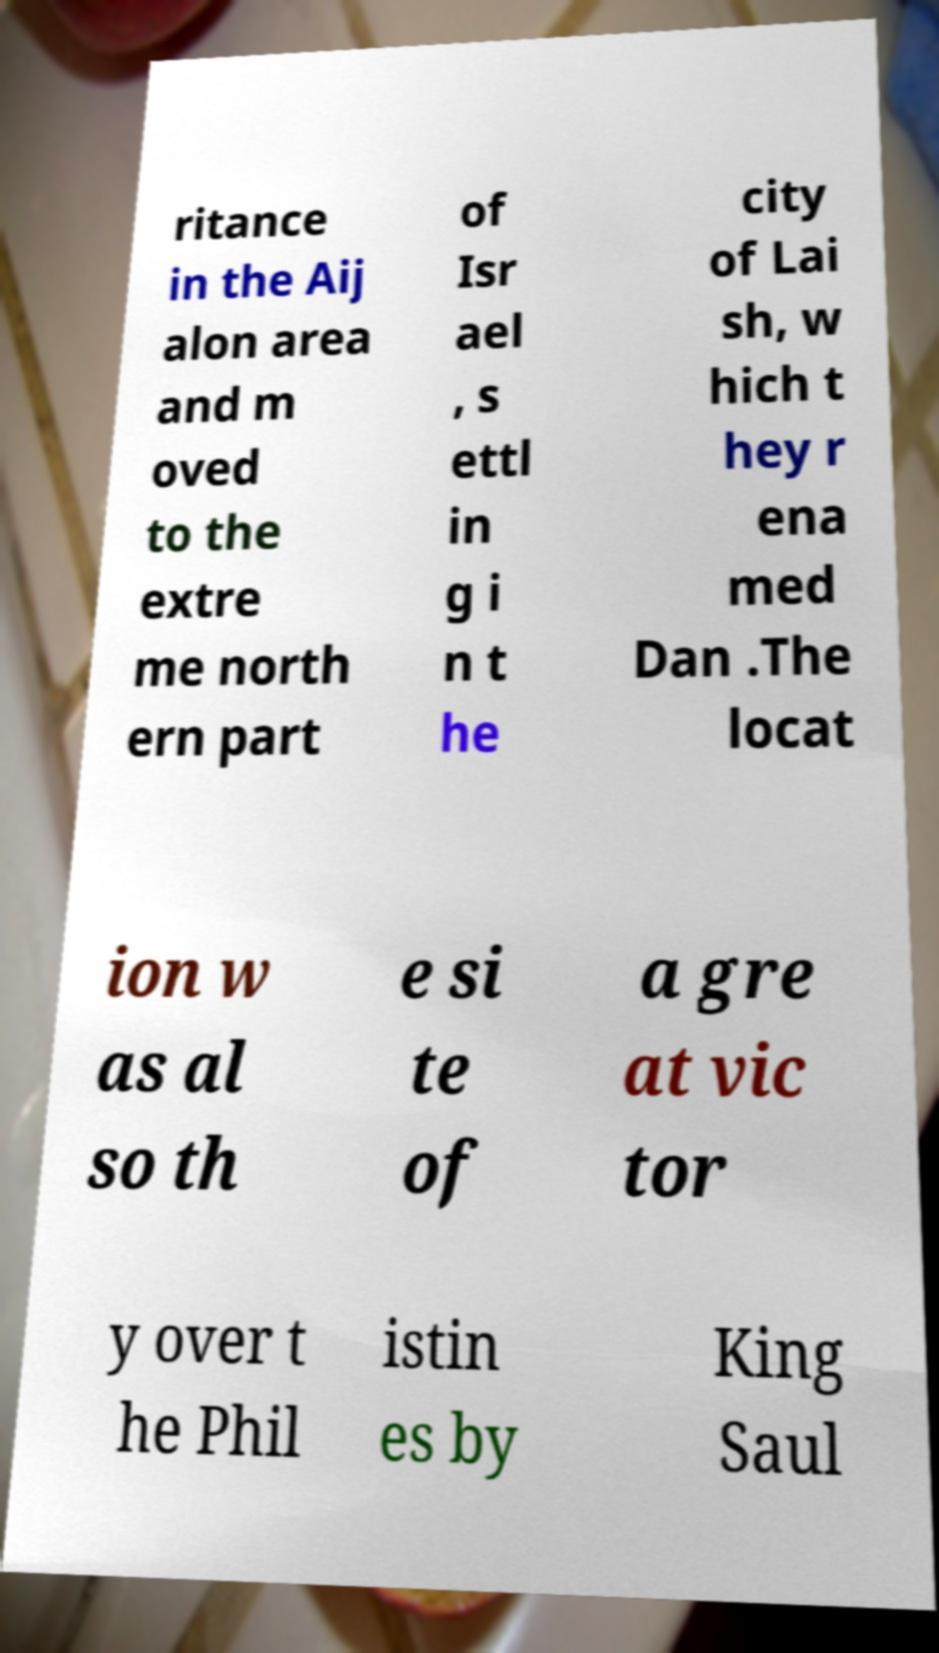Can you accurately transcribe the text from the provided image for me? ritance in the Aij alon area and m oved to the extre me north ern part of Isr ael , s ettl in g i n t he city of Lai sh, w hich t hey r ena med Dan .The locat ion w as al so th e si te of a gre at vic tor y over t he Phil istin es by King Saul 